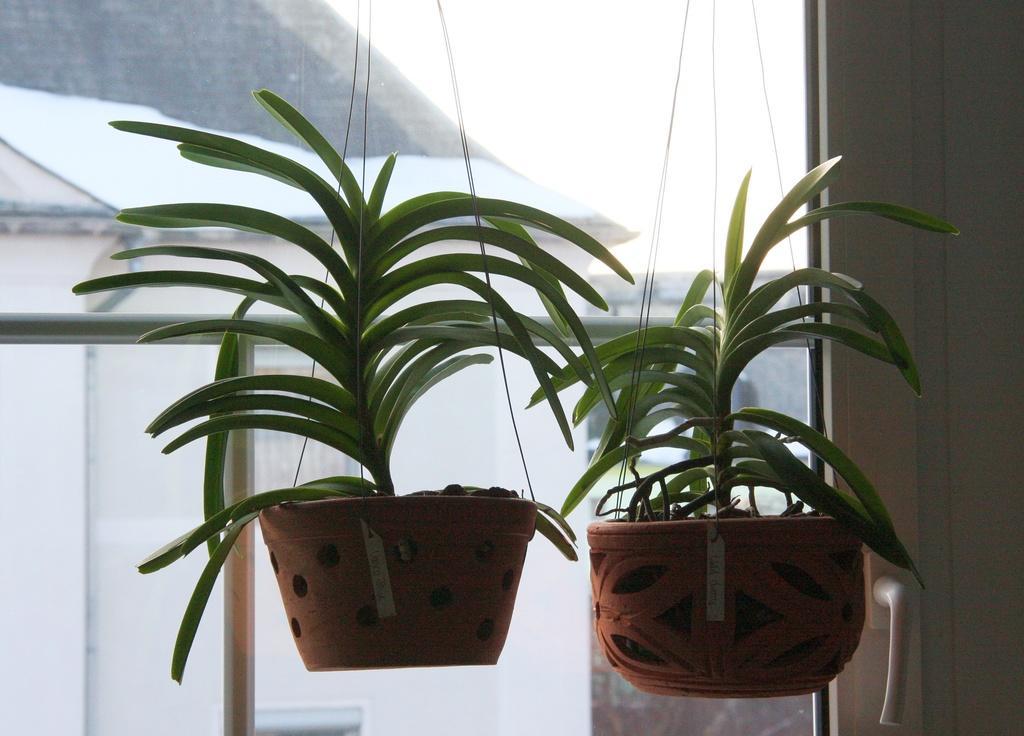Can you describe this image briefly? In this image, we can see plants with pots. On the right side of the image, we can see the door handle. Here we can see glass. Through the glass we can see rods and few things. 